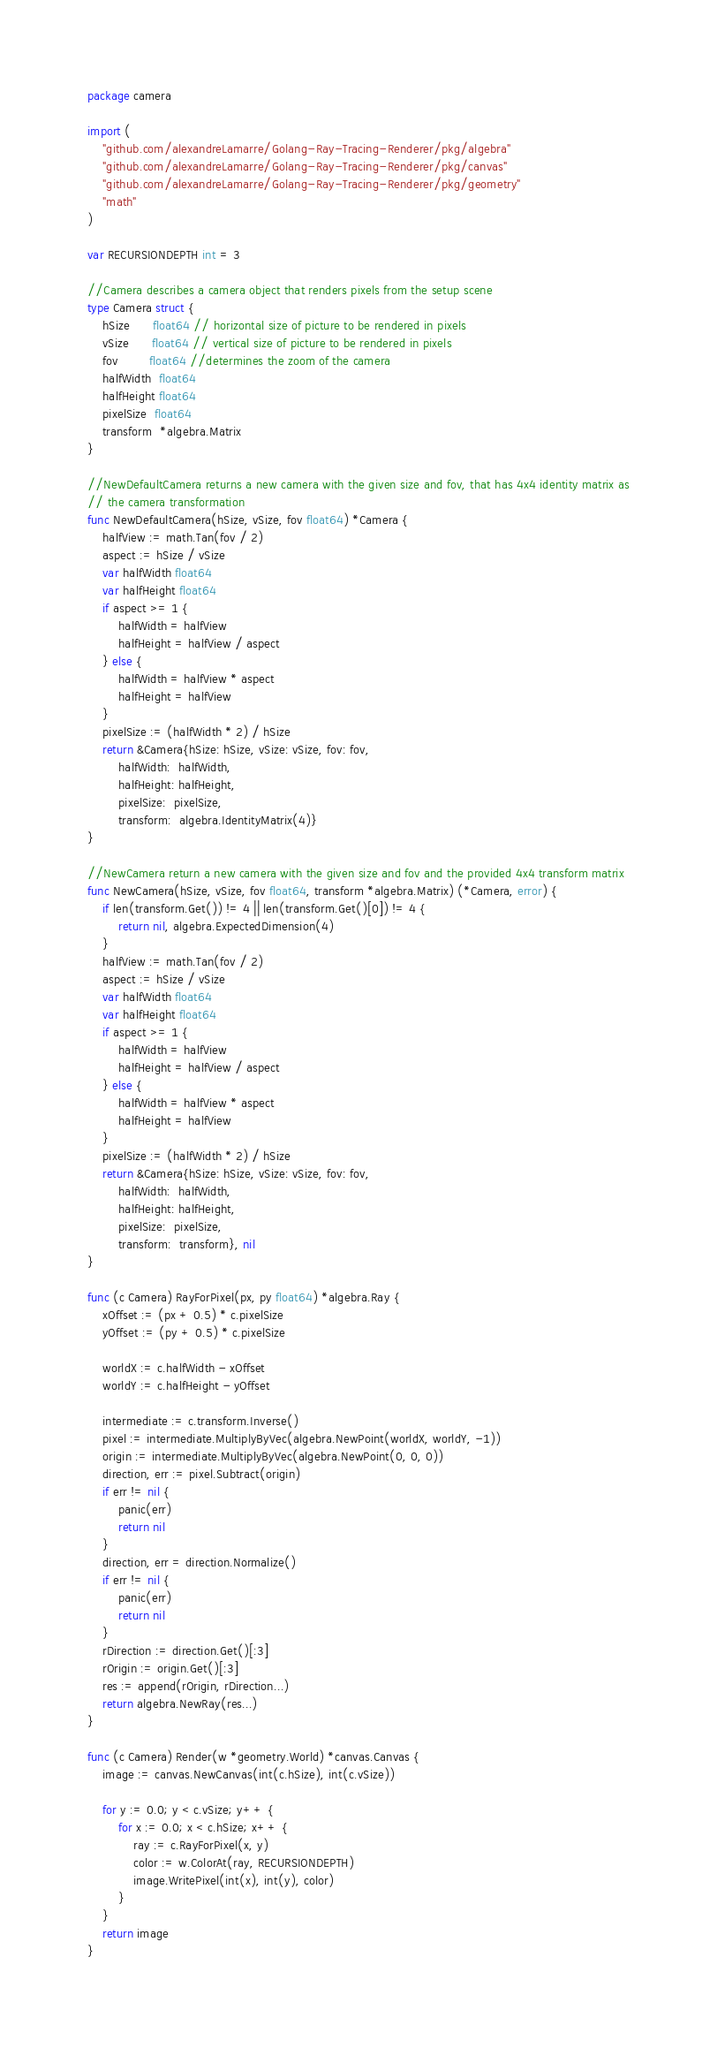<code> <loc_0><loc_0><loc_500><loc_500><_Go_>package camera

import (
	"github.com/alexandreLamarre/Golang-Ray-Tracing-Renderer/pkg/algebra"
	"github.com/alexandreLamarre/Golang-Ray-Tracing-Renderer/pkg/canvas"
	"github.com/alexandreLamarre/Golang-Ray-Tracing-Renderer/pkg/geometry"
	"math"
)

var RECURSIONDEPTH int = 3

//Camera describes a camera object that renders pixels from the setup scene
type Camera struct {
	hSize      float64 // horizontal size of picture to be rendered in pixels
	vSize      float64 // vertical size of picture to be rendered in pixels
	fov        float64 //determines the zoom of the camera
	halfWidth  float64
	halfHeight float64
	pixelSize  float64
	transform  *algebra.Matrix
}

//NewDefaultCamera returns a new camera with the given size and fov, that has 4x4 identity matrix as
// the camera transformation
func NewDefaultCamera(hSize, vSize, fov float64) *Camera {
	halfView := math.Tan(fov / 2)
	aspect := hSize / vSize
	var halfWidth float64
	var halfHeight float64
	if aspect >= 1 {
		halfWidth = halfView
		halfHeight = halfView / aspect
	} else {
		halfWidth = halfView * aspect
		halfHeight = halfView
	}
	pixelSize := (halfWidth * 2) / hSize
	return &Camera{hSize: hSize, vSize: vSize, fov: fov,
		halfWidth:  halfWidth,
		halfHeight: halfHeight,
		pixelSize:  pixelSize,
		transform:  algebra.IdentityMatrix(4)}
}

//NewCamera return a new camera with the given size and fov and the provided 4x4 transform matrix
func NewCamera(hSize, vSize, fov float64, transform *algebra.Matrix) (*Camera, error) {
	if len(transform.Get()) != 4 || len(transform.Get()[0]) != 4 {
		return nil, algebra.ExpectedDimension(4)
	}
	halfView := math.Tan(fov / 2)
	aspect := hSize / vSize
	var halfWidth float64
	var halfHeight float64
	if aspect >= 1 {
		halfWidth = halfView
		halfHeight = halfView / aspect
	} else {
		halfWidth = halfView * aspect
		halfHeight = halfView
	}
	pixelSize := (halfWidth * 2) / hSize
	return &Camera{hSize: hSize, vSize: vSize, fov: fov,
		halfWidth:  halfWidth,
		halfHeight: halfHeight,
		pixelSize:  pixelSize,
		transform:  transform}, nil
}

func (c Camera) RayForPixel(px, py float64) *algebra.Ray {
	xOffset := (px + 0.5) * c.pixelSize
	yOffset := (py + 0.5) * c.pixelSize

	worldX := c.halfWidth - xOffset
	worldY := c.halfHeight - yOffset

	intermediate := c.transform.Inverse()
	pixel := intermediate.MultiplyByVec(algebra.NewPoint(worldX, worldY, -1))
	origin := intermediate.MultiplyByVec(algebra.NewPoint(0, 0, 0))
	direction, err := pixel.Subtract(origin)
	if err != nil {
		panic(err)
		return nil
	}
	direction, err = direction.Normalize()
	if err != nil {
		panic(err)
		return nil
	}
	rDirection := direction.Get()[:3]
	rOrigin := origin.Get()[:3]
	res := append(rOrigin, rDirection...)
	return algebra.NewRay(res...)
}

func (c Camera) Render(w *geometry.World) *canvas.Canvas {
	image := canvas.NewCanvas(int(c.hSize), int(c.vSize))

	for y := 0.0; y < c.vSize; y++ {
		for x := 0.0; x < c.hSize; x++ {
			ray := c.RayForPixel(x, y)
			color := w.ColorAt(ray, RECURSIONDEPTH)
			image.WritePixel(int(x), int(y), color)
		}
	}
	return image
}
</code> 